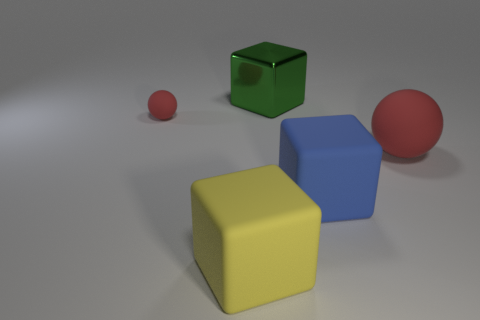There is a red matte object right of the yellow rubber cube; is its size the same as the green metallic block?
Ensure brevity in your answer.  Yes. How big is the block that is both in front of the big metallic thing and to the right of the large yellow cube?
Make the answer very short. Large. How big is the rubber sphere on the left side of the large blue rubber thing?
Offer a terse response. Small. Is the color of the tiny sphere the same as the big matte ball?
Ensure brevity in your answer.  Yes. Is the number of big yellow matte objects that are right of the big red matte thing the same as the number of yellow things to the left of the small thing?
Your answer should be compact. Yes. The big metal block has what color?
Offer a very short reply. Green. How many metal objects are big red balls or tiny blue blocks?
Provide a short and direct response. 0. What is the color of the other rubber object that is the same shape as the big blue thing?
Keep it short and to the point. Yellow. Are there any yellow rubber things?
Your response must be concise. Yes. Is the big cube in front of the blue rubber thing made of the same material as the red object on the right side of the big shiny cube?
Make the answer very short. Yes. 